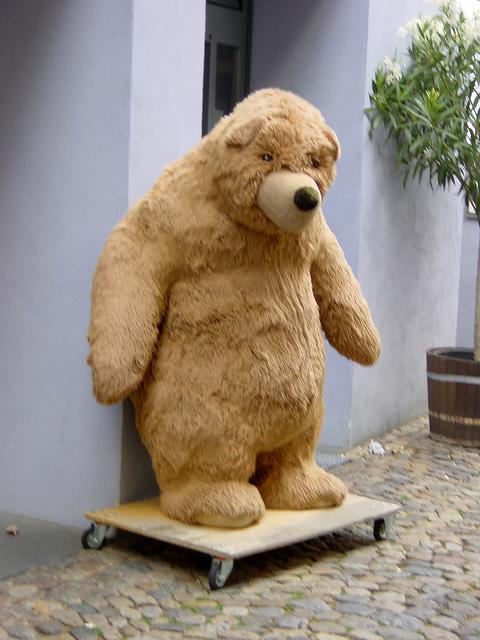Is the bear alive?
Short answer required. No. Is the teddy bear normal size?
Quick response, please. No. How does the bear's platform move?
Answer briefly. Wheels. Where is the bear laying?
Give a very brief answer. Wall. What giant toy is this?
Give a very brief answer. Bear. 